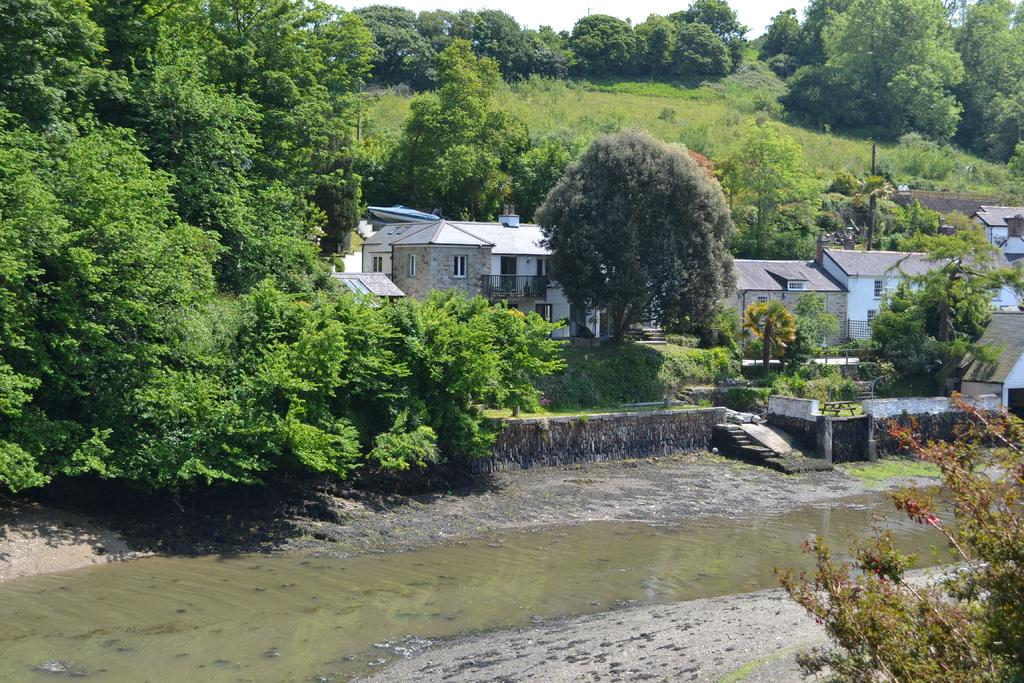What is present at the bottom of the image? There is water at the bottom side of the image. What can be seen in the distance in the image? There are houses and trees in the background of the image. What is the fifth word in the image? There are no words present in the image, so it is not possible to determine the fifth word. 